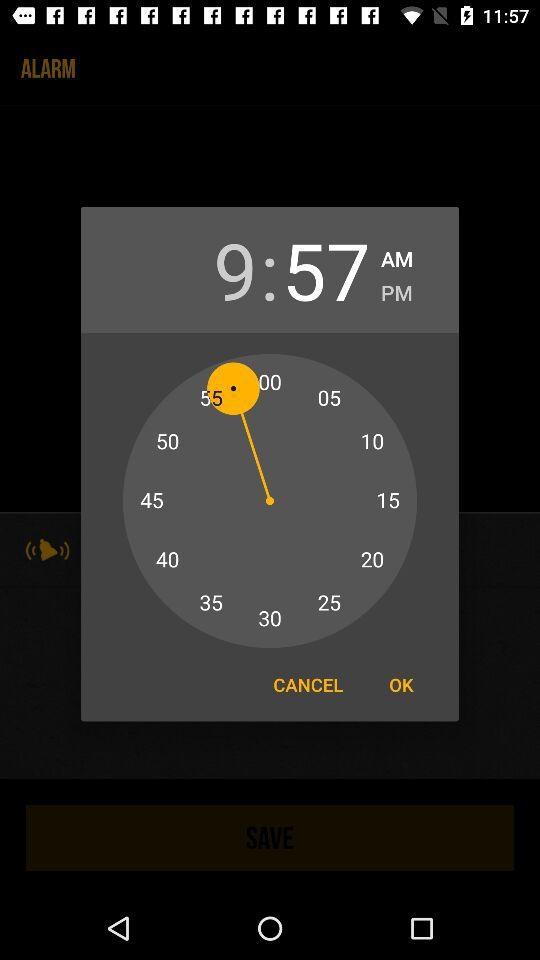How many minutes are between 9 and 57?
Answer the question using a single word or phrase. 48 